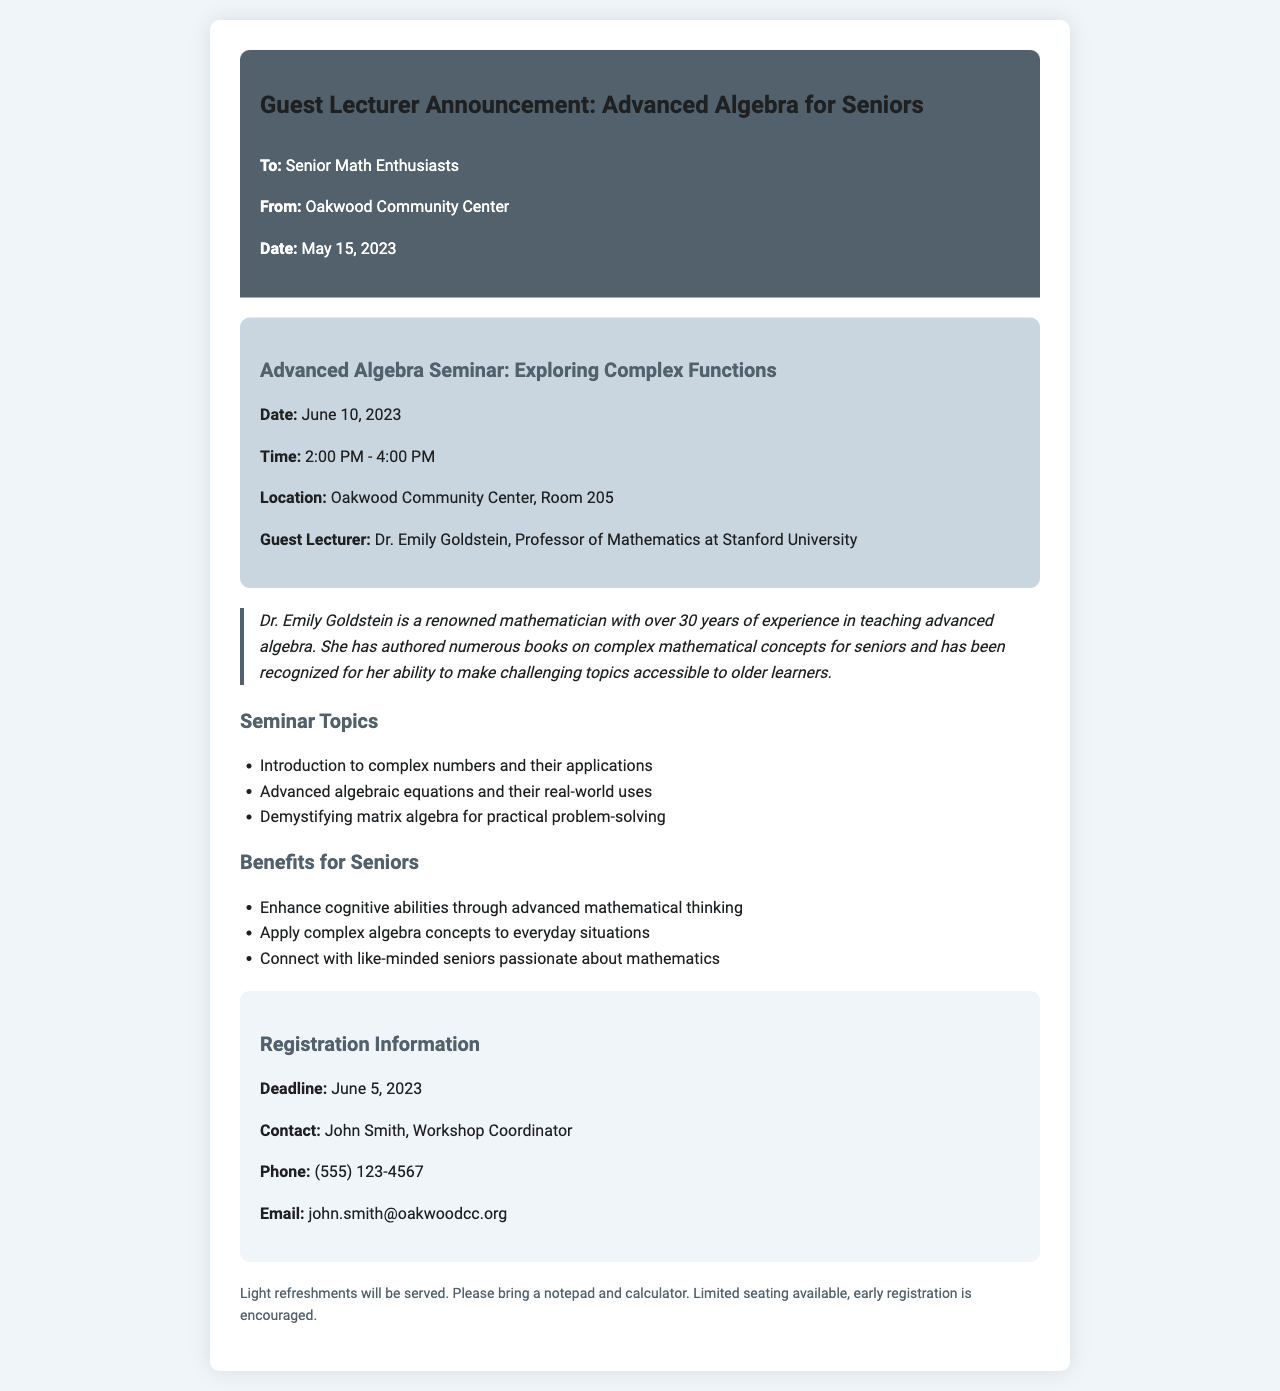what is the date of the seminar? The date of the seminar is provided in the document as June 10, 2023.
Answer: June 10, 2023 who is the guest lecturer? The guest lecturer is mentioned in the document as Dr. Emily Goldstein.
Answer: Dr. Emily Goldstein what room will the seminar be held in? The document specifies that the seminar will take place in Room 205.
Answer: Room 205 what is the registration deadline? The registration deadline is explicitly stated as June 5, 2023.
Answer: June 5, 2023 what are the benefits of attending the seminar? The benefits listed in the document include enhancing cognitive abilities and applying complex algebra concepts.
Answer: Enhance cognitive abilities through advanced mathematical thinking how long is the seminar scheduled for? The seminar time frame is from 2:00 PM to 4:00 PM, which totals 2 hours.
Answer: 2 hours who should be contacted for registration? The document names John Smith as the contact person for registration inquiries.
Answer: John Smith what type of refreshments will be served? The document mentions that light refreshments will be served at the seminar.
Answer: Light refreshments how many years of experience does Dr. Emily Goldstein have? Dr. Emily Goldstein is noted to have over 30 years of experience in teaching advanced algebra.
Answer: Over 30 years 